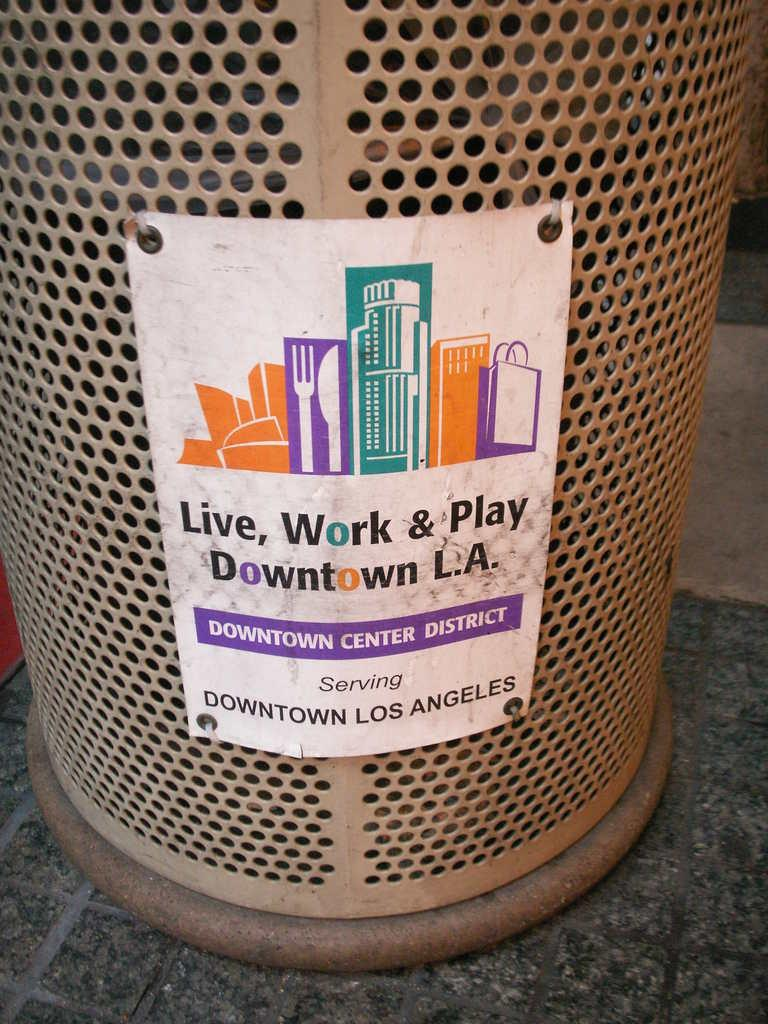<image>
Present a compact description of the photo's key features. trash can in the street that reads live, work and play 